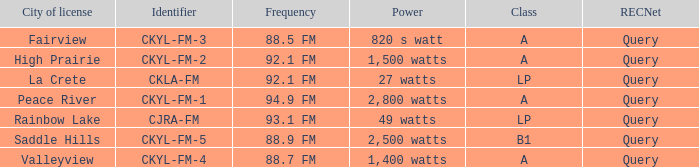What is the identifier for the 9 CKYL-FM-1. 